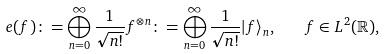<formula> <loc_0><loc_0><loc_500><loc_500>e ( f ) \colon = \bigoplus _ { n = 0 } ^ { \infty } \frac { 1 } { \sqrt { n ! } } f ^ { \otimes n } \colon = \bigoplus _ { n = 0 } ^ { \infty } \frac { 1 } { \sqrt { n ! } } | f \rangle _ { n } , \quad f \in L ^ { 2 } ( \mathbb { R } ) ,</formula> 